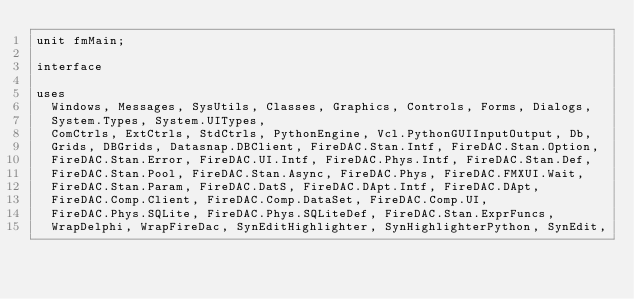<code> <loc_0><loc_0><loc_500><loc_500><_Pascal_>unit fmMain;

interface

uses
  Windows, Messages, SysUtils, Classes, Graphics, Controls, Forms, Dialogs,
  System.Types, System.UITypes,
  ComCtrls, ExtCtrls, StdCtrls, PythonEngine, Vcl.PythonGUIInputOutput, Db,
  Grids, DBGrids, Datasnap.DBClient, FireDAC.Stan.Intf, FireDAC.Stan.Option,
  FireDAC.Stan.Error, FireDAC.UI.Intf, FireDAC.Phys.Intf, FireDAC.Stan.Def,
  FireDAC.Stan.Pool, FireDAC.Stan.Async, FireDAC.Phys, FireDAC.FMXUI.Wait,
  FireDAC.Stan.Param, FireDAC.DatS, FireDAC.DApt.Intf, FireDAC.DApt,
  FireDAC.Comp.Client, FireDAC.Comp.DataSet, FireDAC.Comp.UI,
  FireDAC.Phys.SQLite, FireDAC.Phys.SQLiteDef, FireDAC.Stan.ExprFuncs,
  WrapDelphi, WrapFireDac, SynEditHighlighter, SynHighlighterPython, SynEdit,</code> 